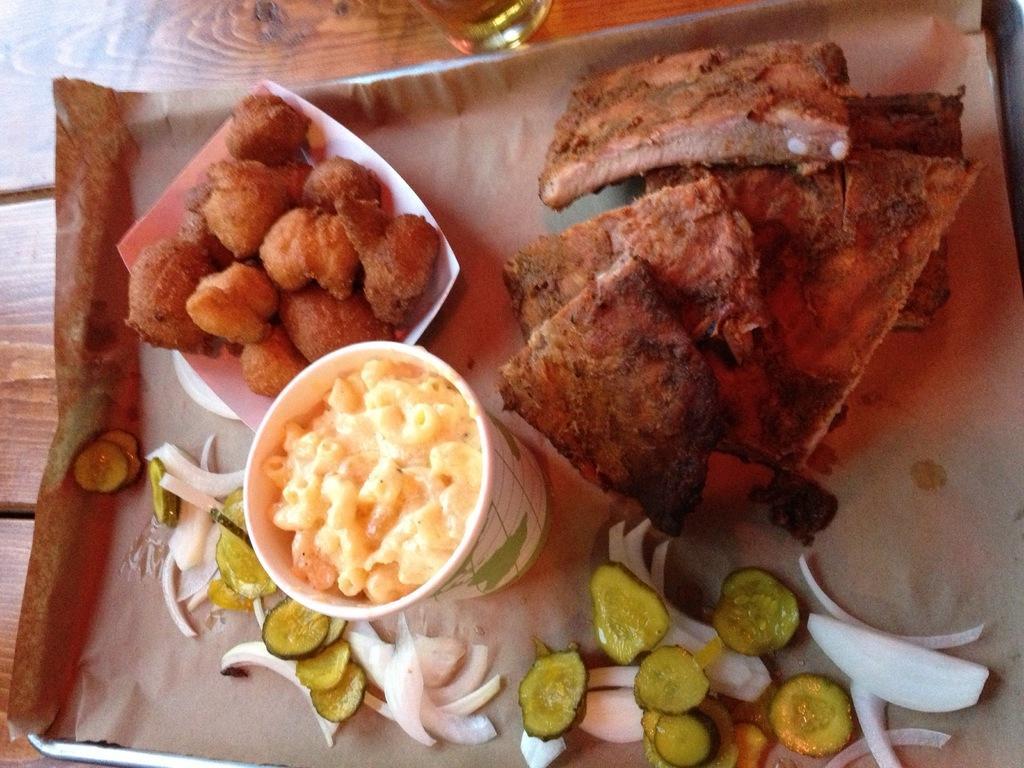In one or two sentences, can you explain what this image depicts? In this image, we can see a plate on the table contains some food. 